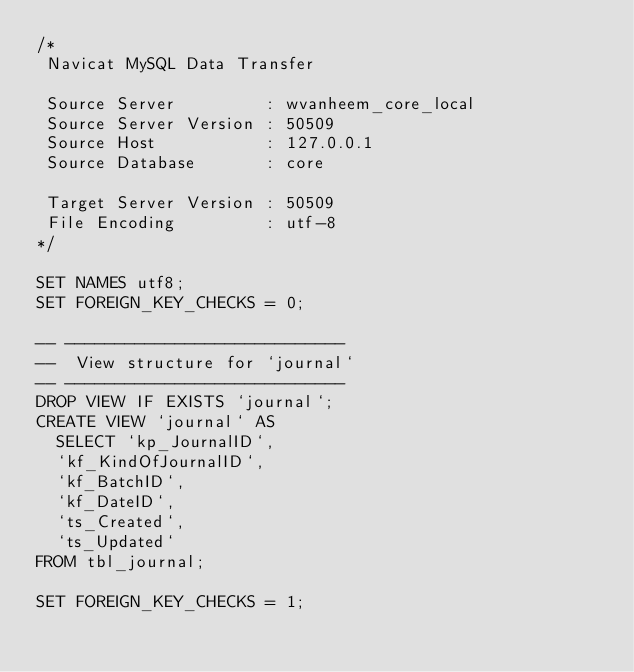Convert code to text. <code><loc_0><loc_0><loc_500><loc_500><_SQL_>/*
 Navicat MySQL Data Transfer

 Source Server         : wvanheem_core_local
 Source Server Version : 50509
 Source Host           : 127.0.0.1
 Source Database       : core

 Target Server Version : 50509
 File Encoding         : utf-8
*/

SET NAMES utf8;
SET FOREIGN_KEY_CHECKS = 0;

-- ----------------------------
--  View structure for `journal`
-- ----------------------------
DROP VIEW IF EXISTS `journal`;
CREATE VIEW `journal` AS 
  SELECT `kp_JournalID`,
	`kf_KindOfJournalID`,
	`kf_BatchID`,
	`kf_DateID`,
	`ts_Created`,
	`ts_Updated`
FROM tbl_journal;

SET FOREIGN_KEY_CHECKS = 1;</code> 